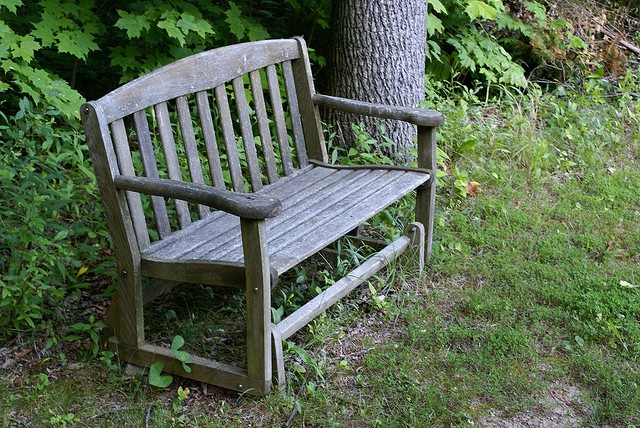Describe the objects in this image and their specific colors. I can see a bench in green, black, darkgray, and gray tones in this image. 